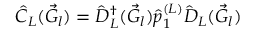<formula> <loc_0><loc_0><loc_500><loc_500>\hat { C } _ { L } ( \vec { G } _ { l } ) = \hat { D } _ { L } ^ { \dagger } ( \vec { G } _ { l } ) \hat { p } _ { 1 } ^ { ( L ) } \hat { D } _ { L } ( \vec { G } _ { l } )</formula> 